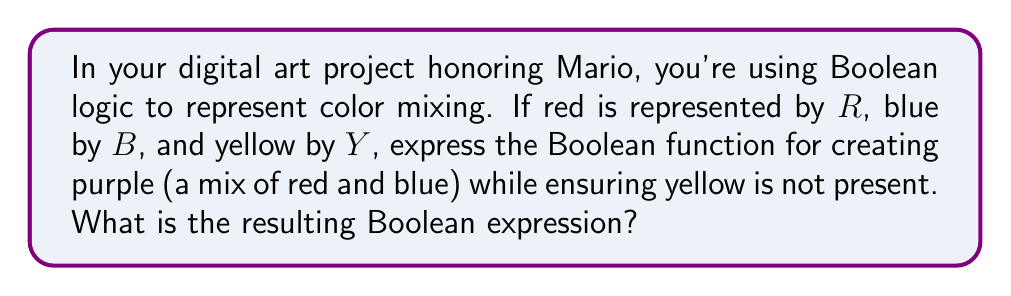Can you solve this math problem? To solve this problem, we'll use Boolean algebra to represent the color mixing process:

1. Purple is created by mixing red and blue. In Boolean terms, this is represented by the AND operation: $R \wedge B$

2. We need to ensure yellow is not present. In Boolean terms, this is represented by the NOT operation: $\neg Y$

3. To combine these conditions, we use the AND operation again:
   $(R \wedge B) \wedge (\neg Y)$

4. This expression can be simplified using the associative property of AND:
   $R \wedge B \wedge \neg Y$

This Boolean expression represents the presence of both red and blue (to create purple) AND the absence of yellow.
Answer: $R \wedge B \wedge \neg Y$ 